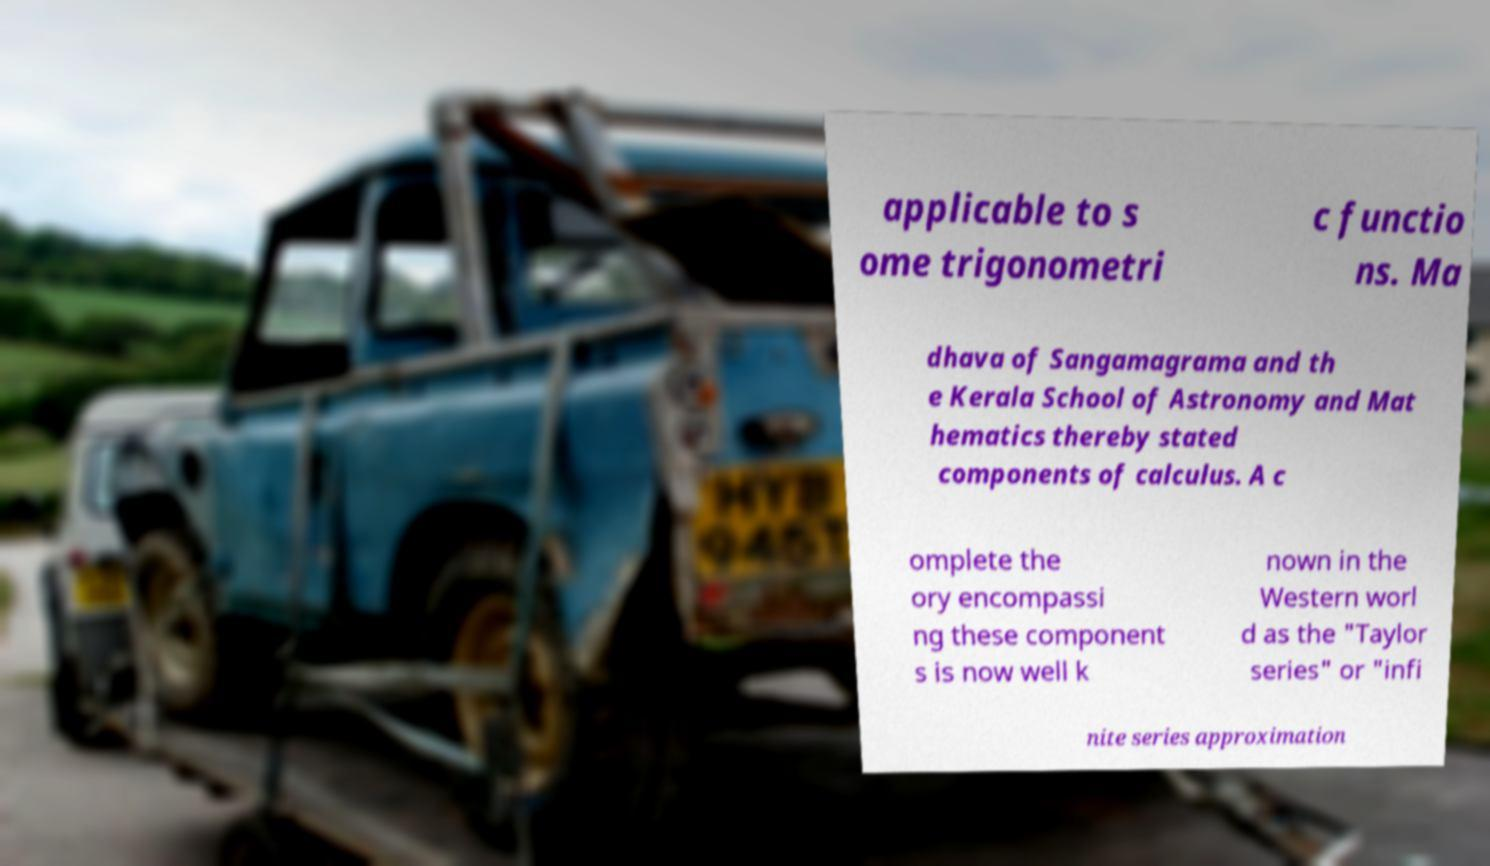For documentation purposes, I need the text within this image transcribed. Could you provide that? applicable to s ome trigonometri c functio ns. Ma dhava of Sangamagrama and th e Kerala School of Astronomy and Mat hematics thereby stated components of calculus. A c omplete the ory encompassi ng these component s is now well k nown in the Western worl d as the "Taylor series" or "infi nite series approximation 